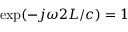<formula> <loc_0><loc_0><loc_500><loc_500>\exp ( - j \omega 2 L / c ) = 1</formula> 